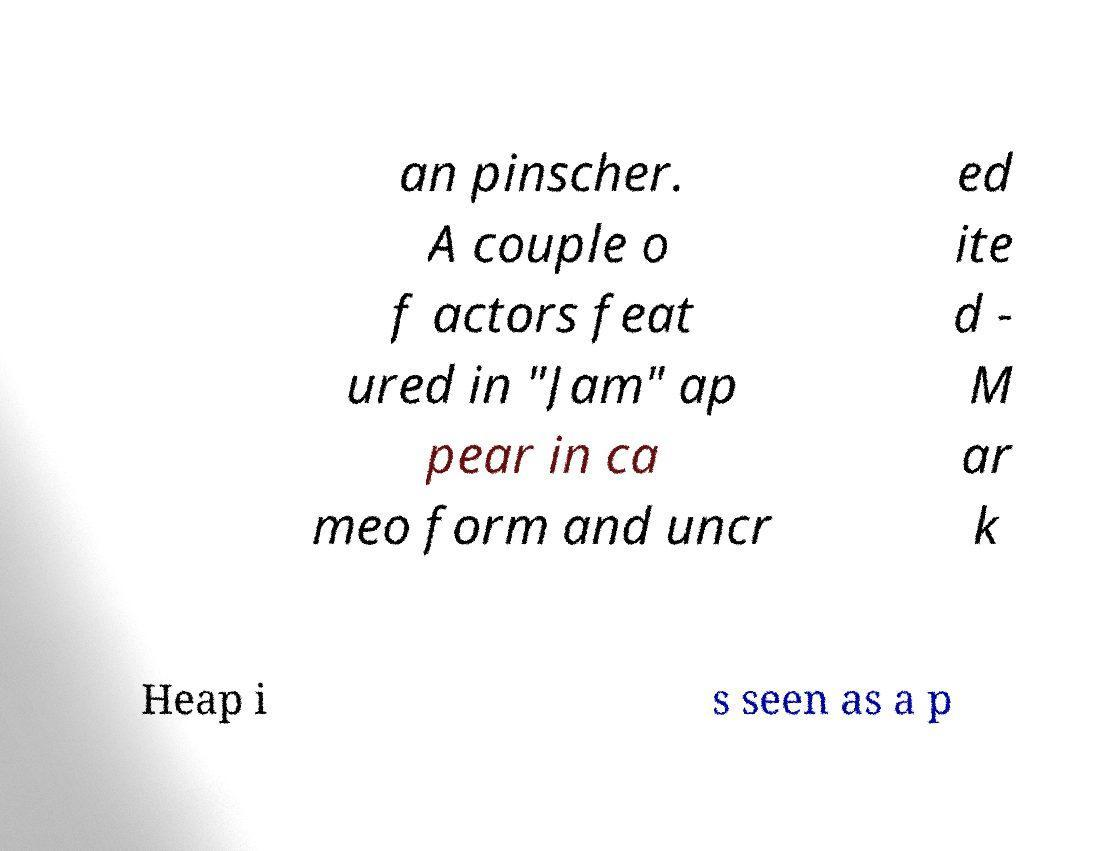Please identify and transcribe the text found in this image. an pinscher. A couple o f actors feat ured in "Jam" ap pear in ca meo form and uncr ed ite d - M ar k Heap i s seen as a p 